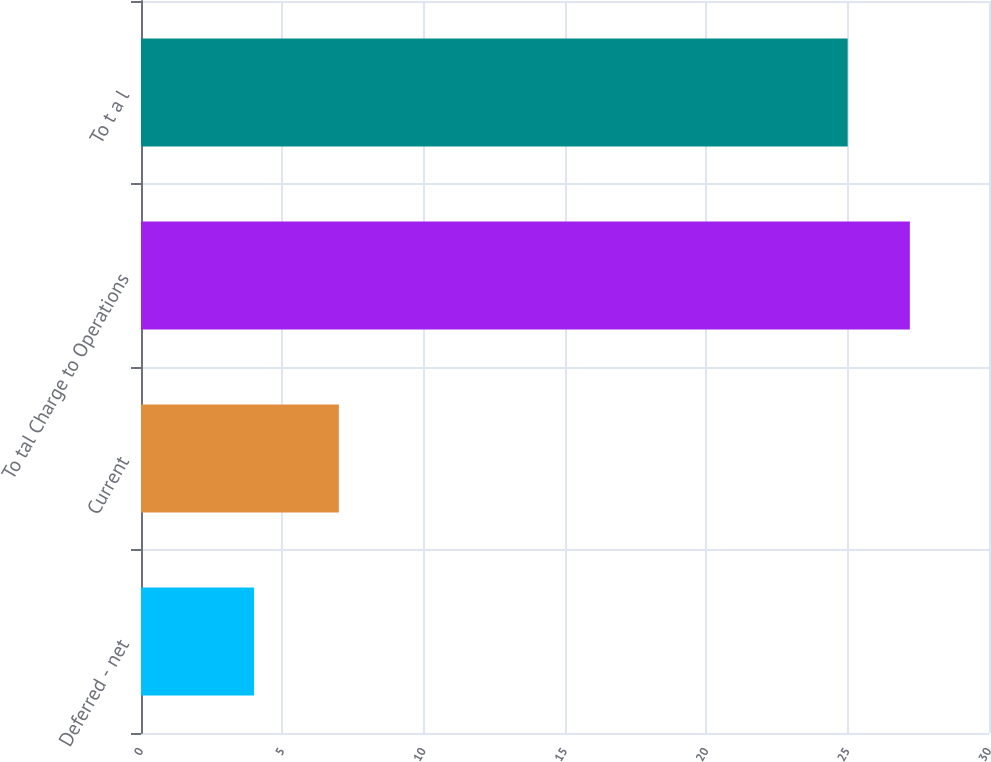Convert chart. <chart><loc_0><loc_0><loc_500><loc_500><bar_chart><fcel>Deferred - net<fcel>Current<fcel>To tal Charge to Operations<fcel>To t a l<nl><fcel>4<fcel>7<fcel>27.2<fcel>25<nl></chart> 